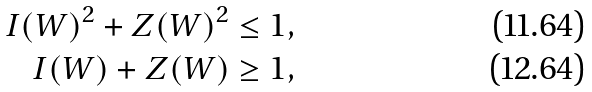<formula> <loc_0><loc_0><loc_500><loc_500>I ( W ) ^ { 2 } + Z ( W ) ^ { 2 } & \leq 1 , \\ I ( W ) + Z ( W ) & \geq 1 ,</formula> 